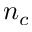<formula> <loc_0><loc_0><loc_500><loc_500>n _ { c }</formula> 